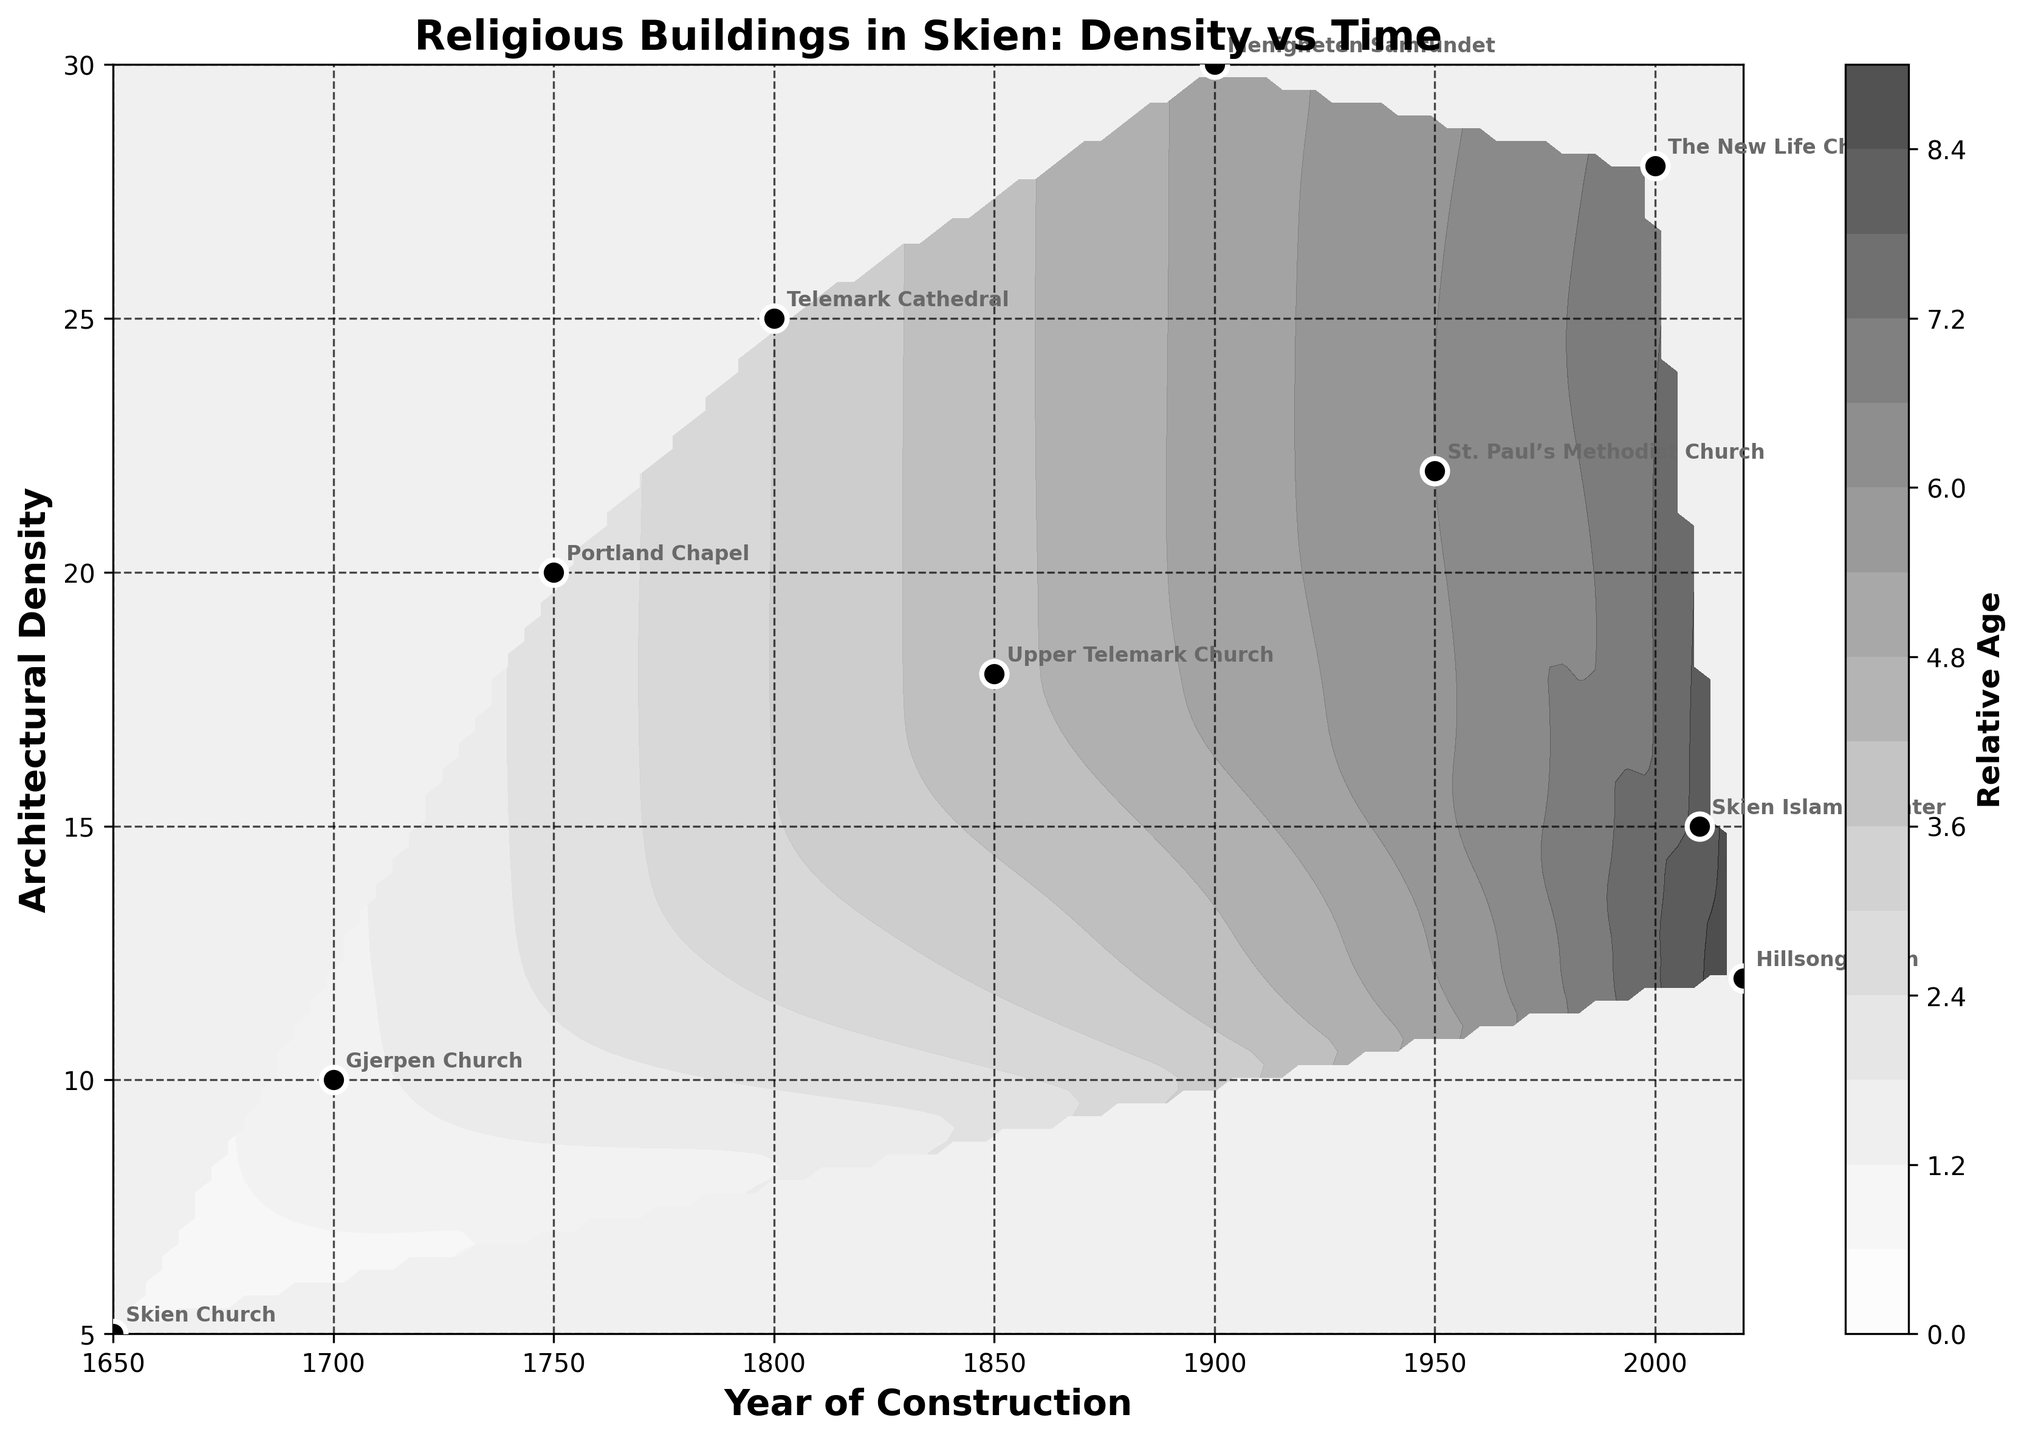What is the title of the plot? The title is displayed prominently at the top of the plot. It provides a summary of what the graph is about.
Answer: Religious Buildings in Skien: Density vs Time What are the labels of the X and Y axes? The labels describe what the axes represent. The X-axis label is at the bottom, and the Y-axis label is on the left side of the plot. The X-axis is labeled 'Year of Construction' and the Y-axis is labeled 'Architectural Density.'
Answer: Year of Construction, Architectural Density How many data points are represented in the plot? The data points are indicated by the black scatter points on the graph. Each scatter point represents one data point. By counting the black scatter points, we can determine the number of data points.
Answer: 10 Which religious building was constructed in 1800, and what is its architectural density? Find the scatter point at the year 1800 on the X-axis and note the corresponding Y-axis value, then read the annotated label near this point for the building name. The building constructed in 1800 is 'Telemark Cathedral' and its architectural density is 25.
Answer: Telemark Cathedral, 25 What is the architectural density of Skien Church, and when was it constructed? Locate the scatter point with the label 'Skien Church' then check the Y and X positions for architectural density and year of construction, respectively. Skien Church has an architectural density of 5 and was constructed in 1650.
Answer: 5, 1650 Which religious building has the highest architectural density, and what is that density? Identify the scatter point with the highest Y-axis value (Architectural Density) and read the annotation to find the building name. 'Menigheten Samfundet' has the highest architectural density of 30.
Answer: Menigheten Samfundet, 30 How many religious buildings were constructed after the year 1950, and what are their names? Look for scatter points with X-axis values greater than 1950, then count these points and note down the labels. The buildings constructed after 1950 are 'The New Life Church,' 'Skien Islamic Center,' and 'Hillsong Skien.' These are 3 buildings.
Answer: 3, The New Life Church, Skien Islamic Center, Hillsong Skien What was the average architectural density for buildings constructed before 1800? Identify the scatter points before 1800, sum their Architectural Density values, and then divide by the number of these points. (Skien Church: 5, Gjerpen Church: 10, Portland Chapel: 20) so, (5 + 10 + 20) / 3 = 35 / 3 ≈ 11.67.
Answer: 11.67 Compare the architectural density of Gjerpen Church and St. Paul’s Methodist Church. Which one is greater? Locate each building on the plot, note their Y-axis values, and compare them. Gjerpen Church has a density of 10, while St. Paul’s Methodist Church has a density of 22. St. Paul’s Methodist Church has a higher density.
Answer: St. Paul’s Methodist Church What does the color gradient in the contour plot represent? Look at the color bar next to the plot, which shows color ranges and their corresponding values. It represents 'Relative Age,' with darker shades indicating older buildings and lighter shades indicating newer buildings.
Answer: Relative Age 